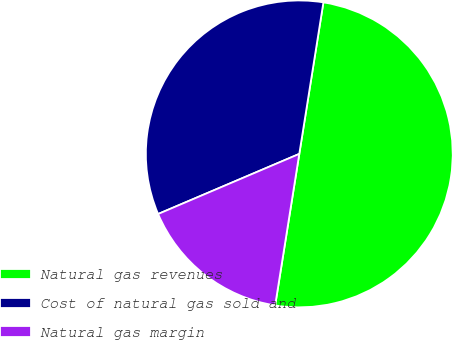Convert chart. <chart><loc_0><loc_0><loc_500><loc_500><pie_chart><fcel>Natural gas revenues<fcel>Cost of natural gas sold and<fcel>Natural gas margin<nl><fcel>50.0%<fcel>33.92%<fcel>16.08%<nl></chart> 